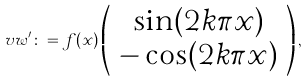Convert formula to latex. <formula><loc_0><loc_0><loc_500><loc_500>\ v w ^ { \prime } \colon = f ( x ) \left ( \begin{array} { c } \sin ( 2 k \pi x ) \\ - \cos ( 2 k \pi x ) \end{array} \right ) ,</formula> 